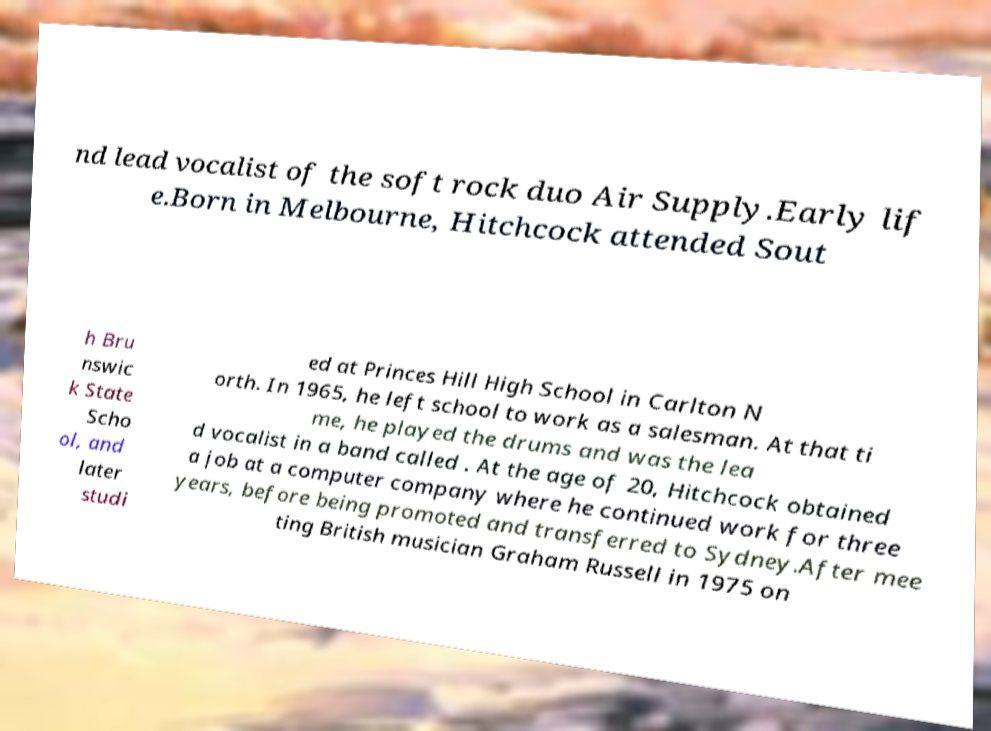Can you read and provide the text displayed in the image?This photo seems to have some interesting text. Can you extract and type it out for me? nd lead vocalist of the soft rock duo Air Supply.Early lif e.Born in Melbourne, Hitchcock attended Sout h Bru nswic k State Scho ol, and later studi ed at Princes Hill High School in Carlton N orth. In 1965, he left school to work as a salesman. At that ti me, he played the drums and was the lea d vocalist in a band called . At the age of 20, Hitchcock obtained a job at a computer company where he continued work for three years, before being promoted and transferred to Sydney.After mee ting British musician Graham Russell in 1975 on 